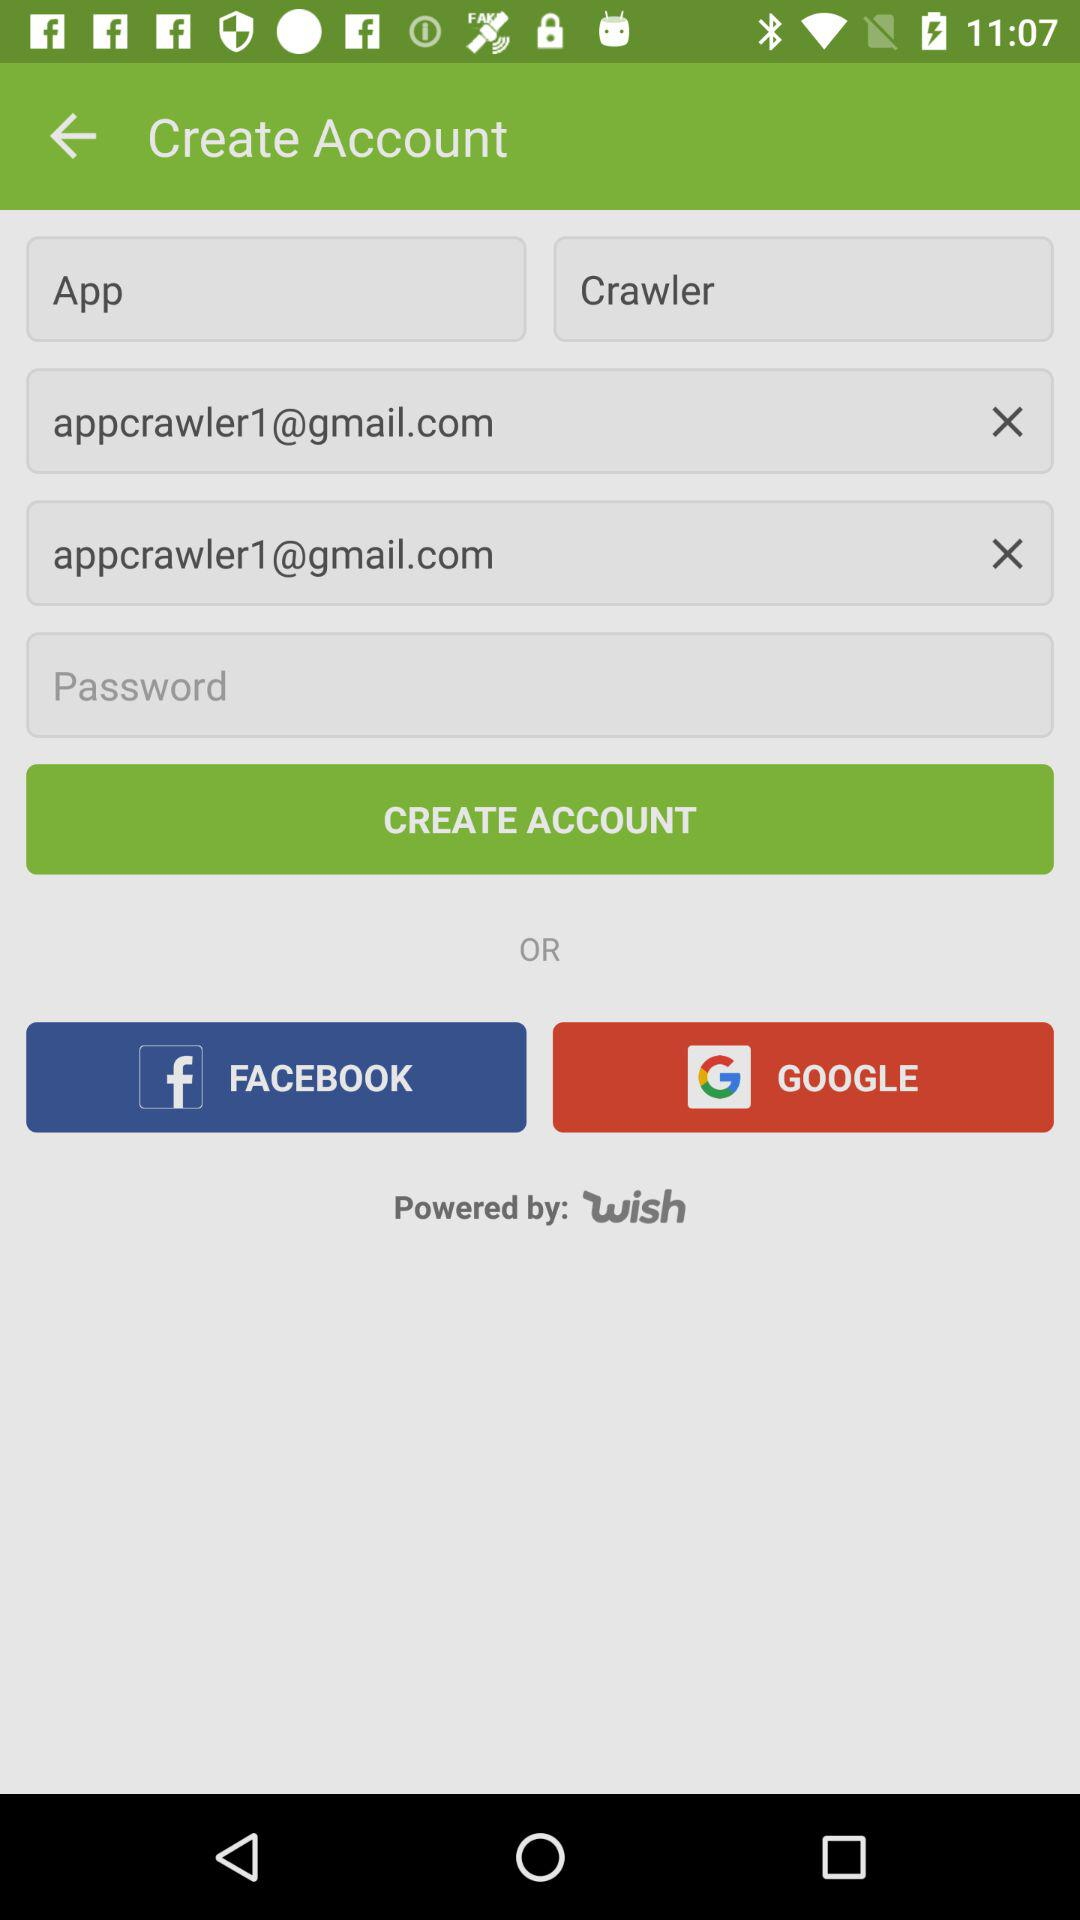What is the name? The name is App Crawler. 